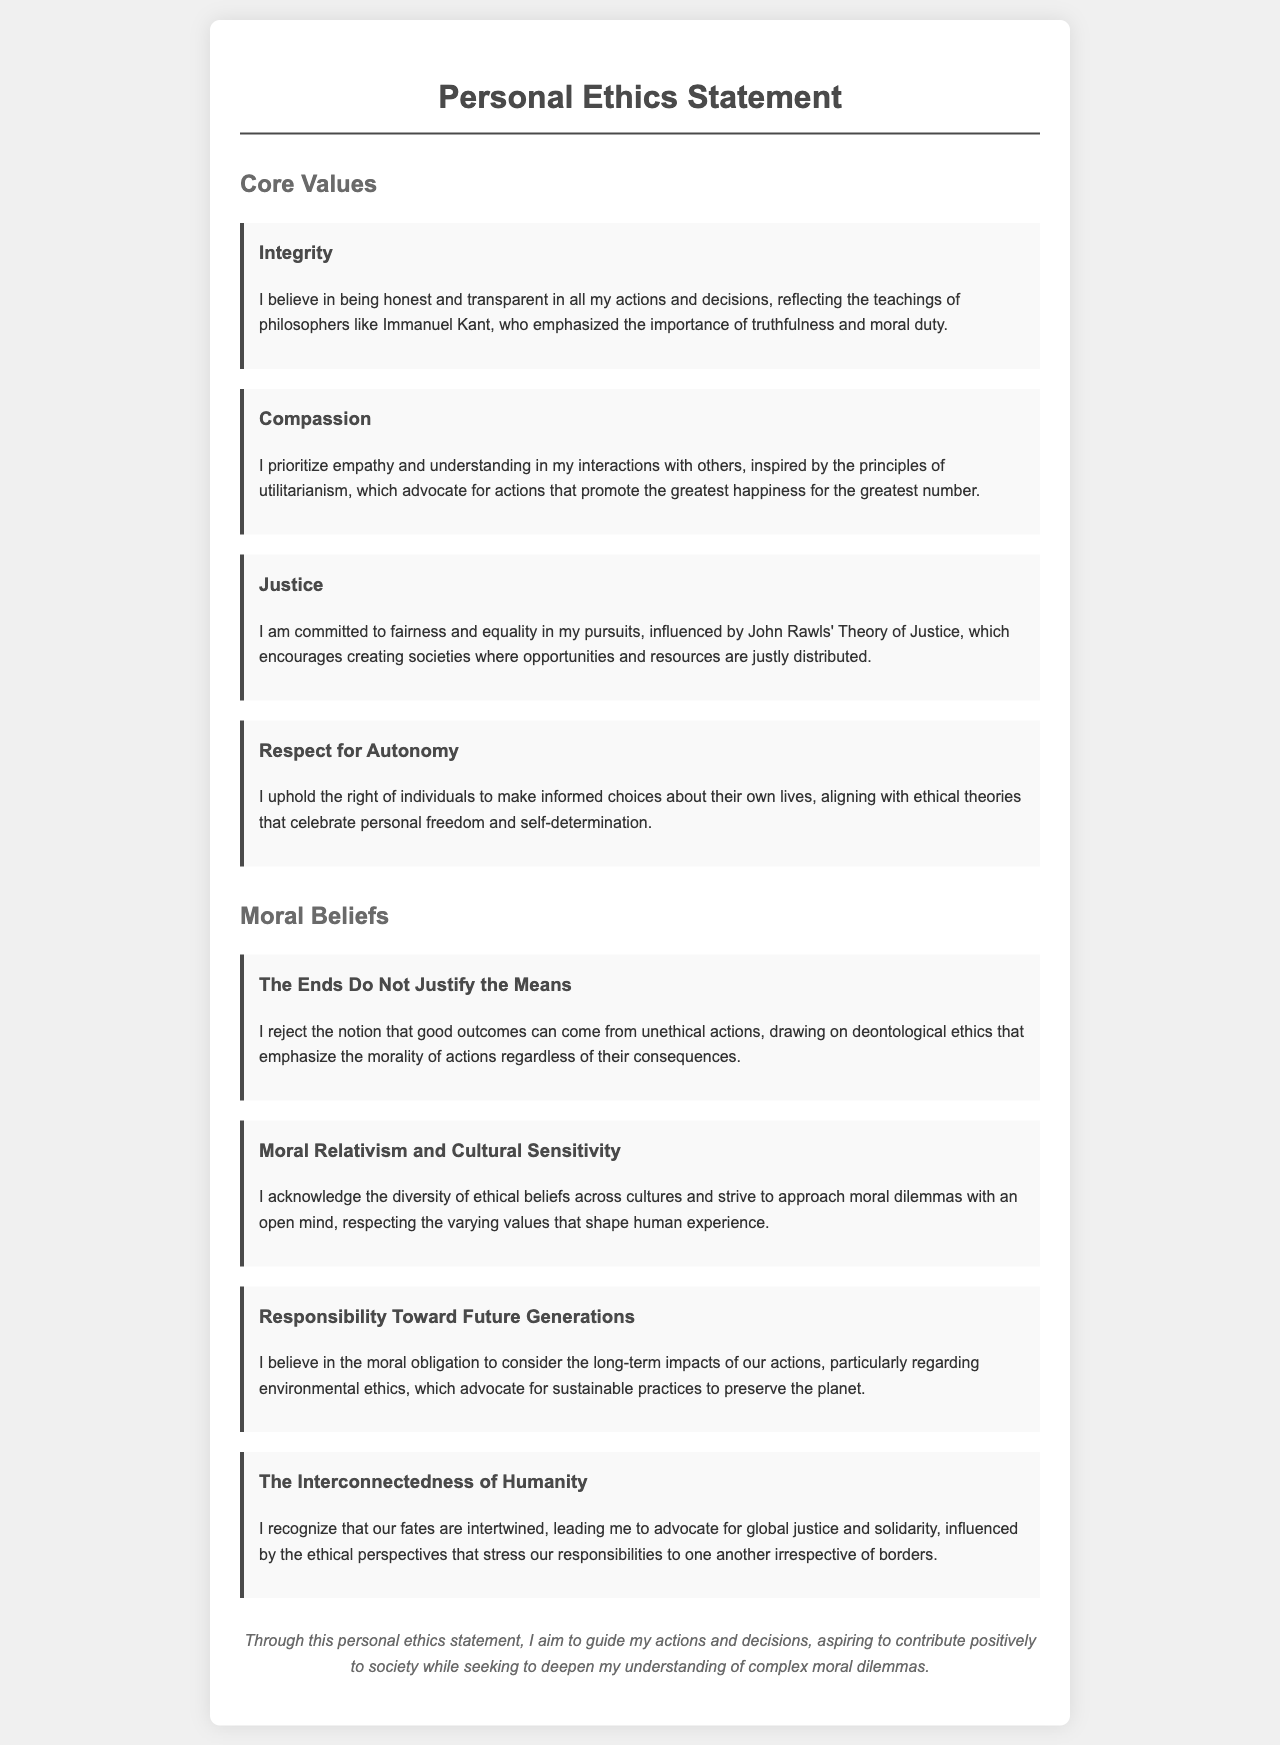What is the title of the document? The title of the document is stated in the header of the HTML, which is "Personal Ethics Statement."
Answer: Personal Ethics Statement Who is mentioned as an influence for Integrity? The influence for Integrity is indicated in the document as the philosopher Immanuel Kant.
Answer: Immanuel Kant What core value emphasizes empathy? The core value that emphasizes empathy is Compassion.
Answer: Compassion How many moral beliefs are listed in the document? The document lists a total of four moral beliefs under the section "Moral Beliefs."
Answer: Four What philosophical theory does the value of Justice relate to? The value of Justice is connected to John Rawls' Theory of Justice, as mentioned in the document.
Answer: John Rawls' Theory of Justice Which ethical perspective is aligned with Respect for Autonomy? Respect for Autonomy is aligned with ethical theories that celebrate personal freedom and self-determination.
Answer: Personal freedom and self-determination What phrase summarizes the belief regarding the ends and means? The phrase that summarizes this belief is "The Ends Do Not Justify the Means."
Answer: The Ends Do Not Justify the Means Which belief discusses obligations toward the environment? The belief that discusses obligations toward the environment is "Responsibility Toward Future Generations."
Answer: Responsibility Toward Future Generations What is a core value mentioned that relates to fairness? The core value that relates to fairness is Justice.
Answer: Justice 